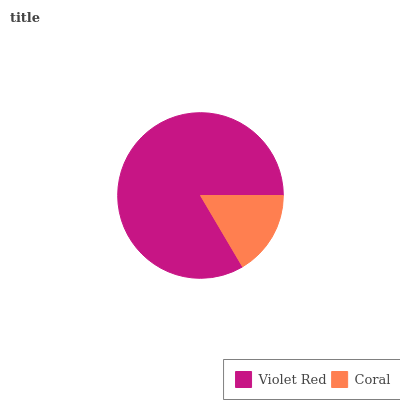Is Coral the minimum?
Answer yes or no. Yes. Is Violet Red the maximum?
Answer yes or no. Yes. Is Coral the maximum?
Answer yes or no. No. Is Violet Red greater than Coral?
Answer yes or no. Yes. Is Coral less than Violet Red?
Answer yes or no. Yes. Is Coral greater than Violet Red?
Answer yes or no. No. Is Violet Red less than Coral?
Answer yes or no. No. Is Violet Red the high median?
Answer yes or no. Yes. Is Coral the low median?
Answer yes or no. Yes. Is Coral the high median?
Answer yes or no. No. Is Violet Red the low median?
Answer yes or no. No. 